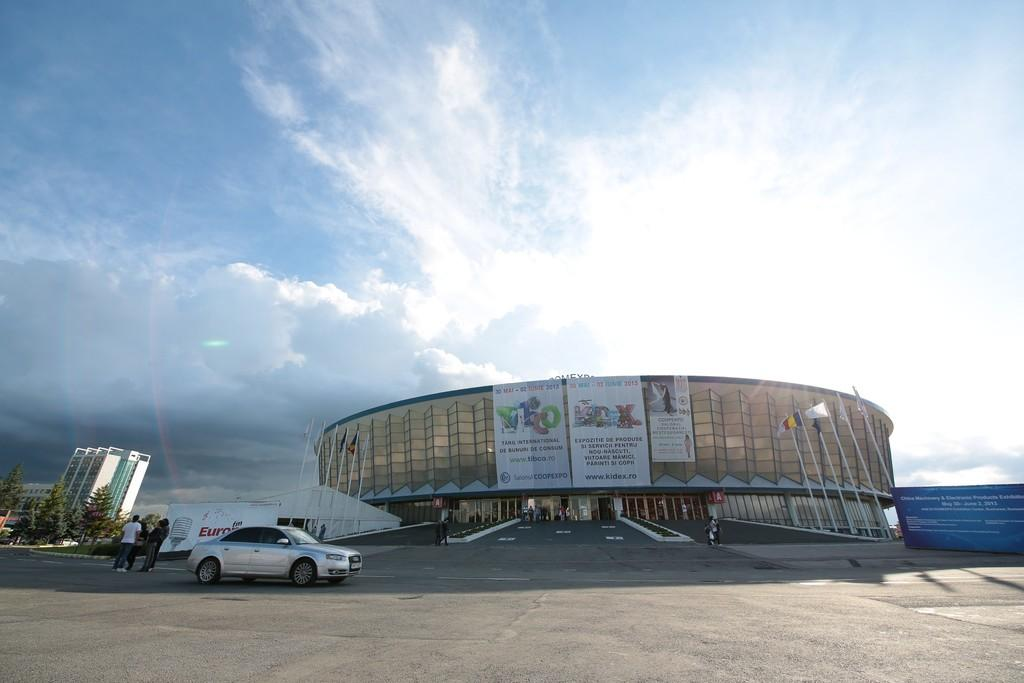What type of structure is visible in the image? There is a building in the image. What mode of transportation can be seen in the image? There is a car in the image. What surface is visible in the image? There is a road in the image. What architectural feature is present in the image? There are steps in the image. Who or what is present in the image? There are persons in the image. What type of vegetation is visible in the image? There are trees in the image. What part of the natural environment is visible in the image? The sky is visible in the image. What atmospheric conditions can be observed in the image? There are clouds in the image. What type of comfort can be seen in the image? There is no specific comfort item or feature present in the image. What type of plants are visible in the image? The image does not show any plants; it features a building, a car, a road, steps, persons, trees, the sky, and clouds. 